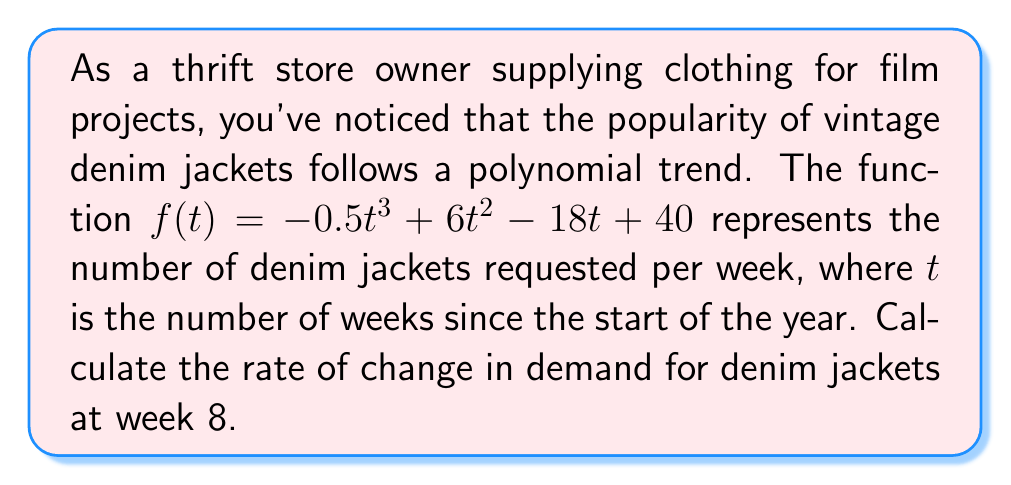Help me with this question. To find the rate of change at a specific point, we need to calculate the derivative of the function and evaluate it at the given point.

Step 1: Find the derivative of $f(t)$.
$f(t) = -0.5t^3 + 6t^2 - 18t + 40$
$f'(t) = -1.5t^2 + 12t - 18$

Step 2: Evaluate the derivative at $t = 8$.
$f'(8) = -1.5(8)^2 + 12(8) - 18$
$= -1.5(64) + 96 - 18$
$= -96 + 96 - 18$
$= -18$

The negative value indicates that the demand for denim jackets is decreasing at week 8.

Step 3: Interpret the result.
The rate of change at week 8 is -18 jackets per week, meaning the demand is decreasing by 18 jackets each week at this point in time.
Answer: -18 jackets per week 